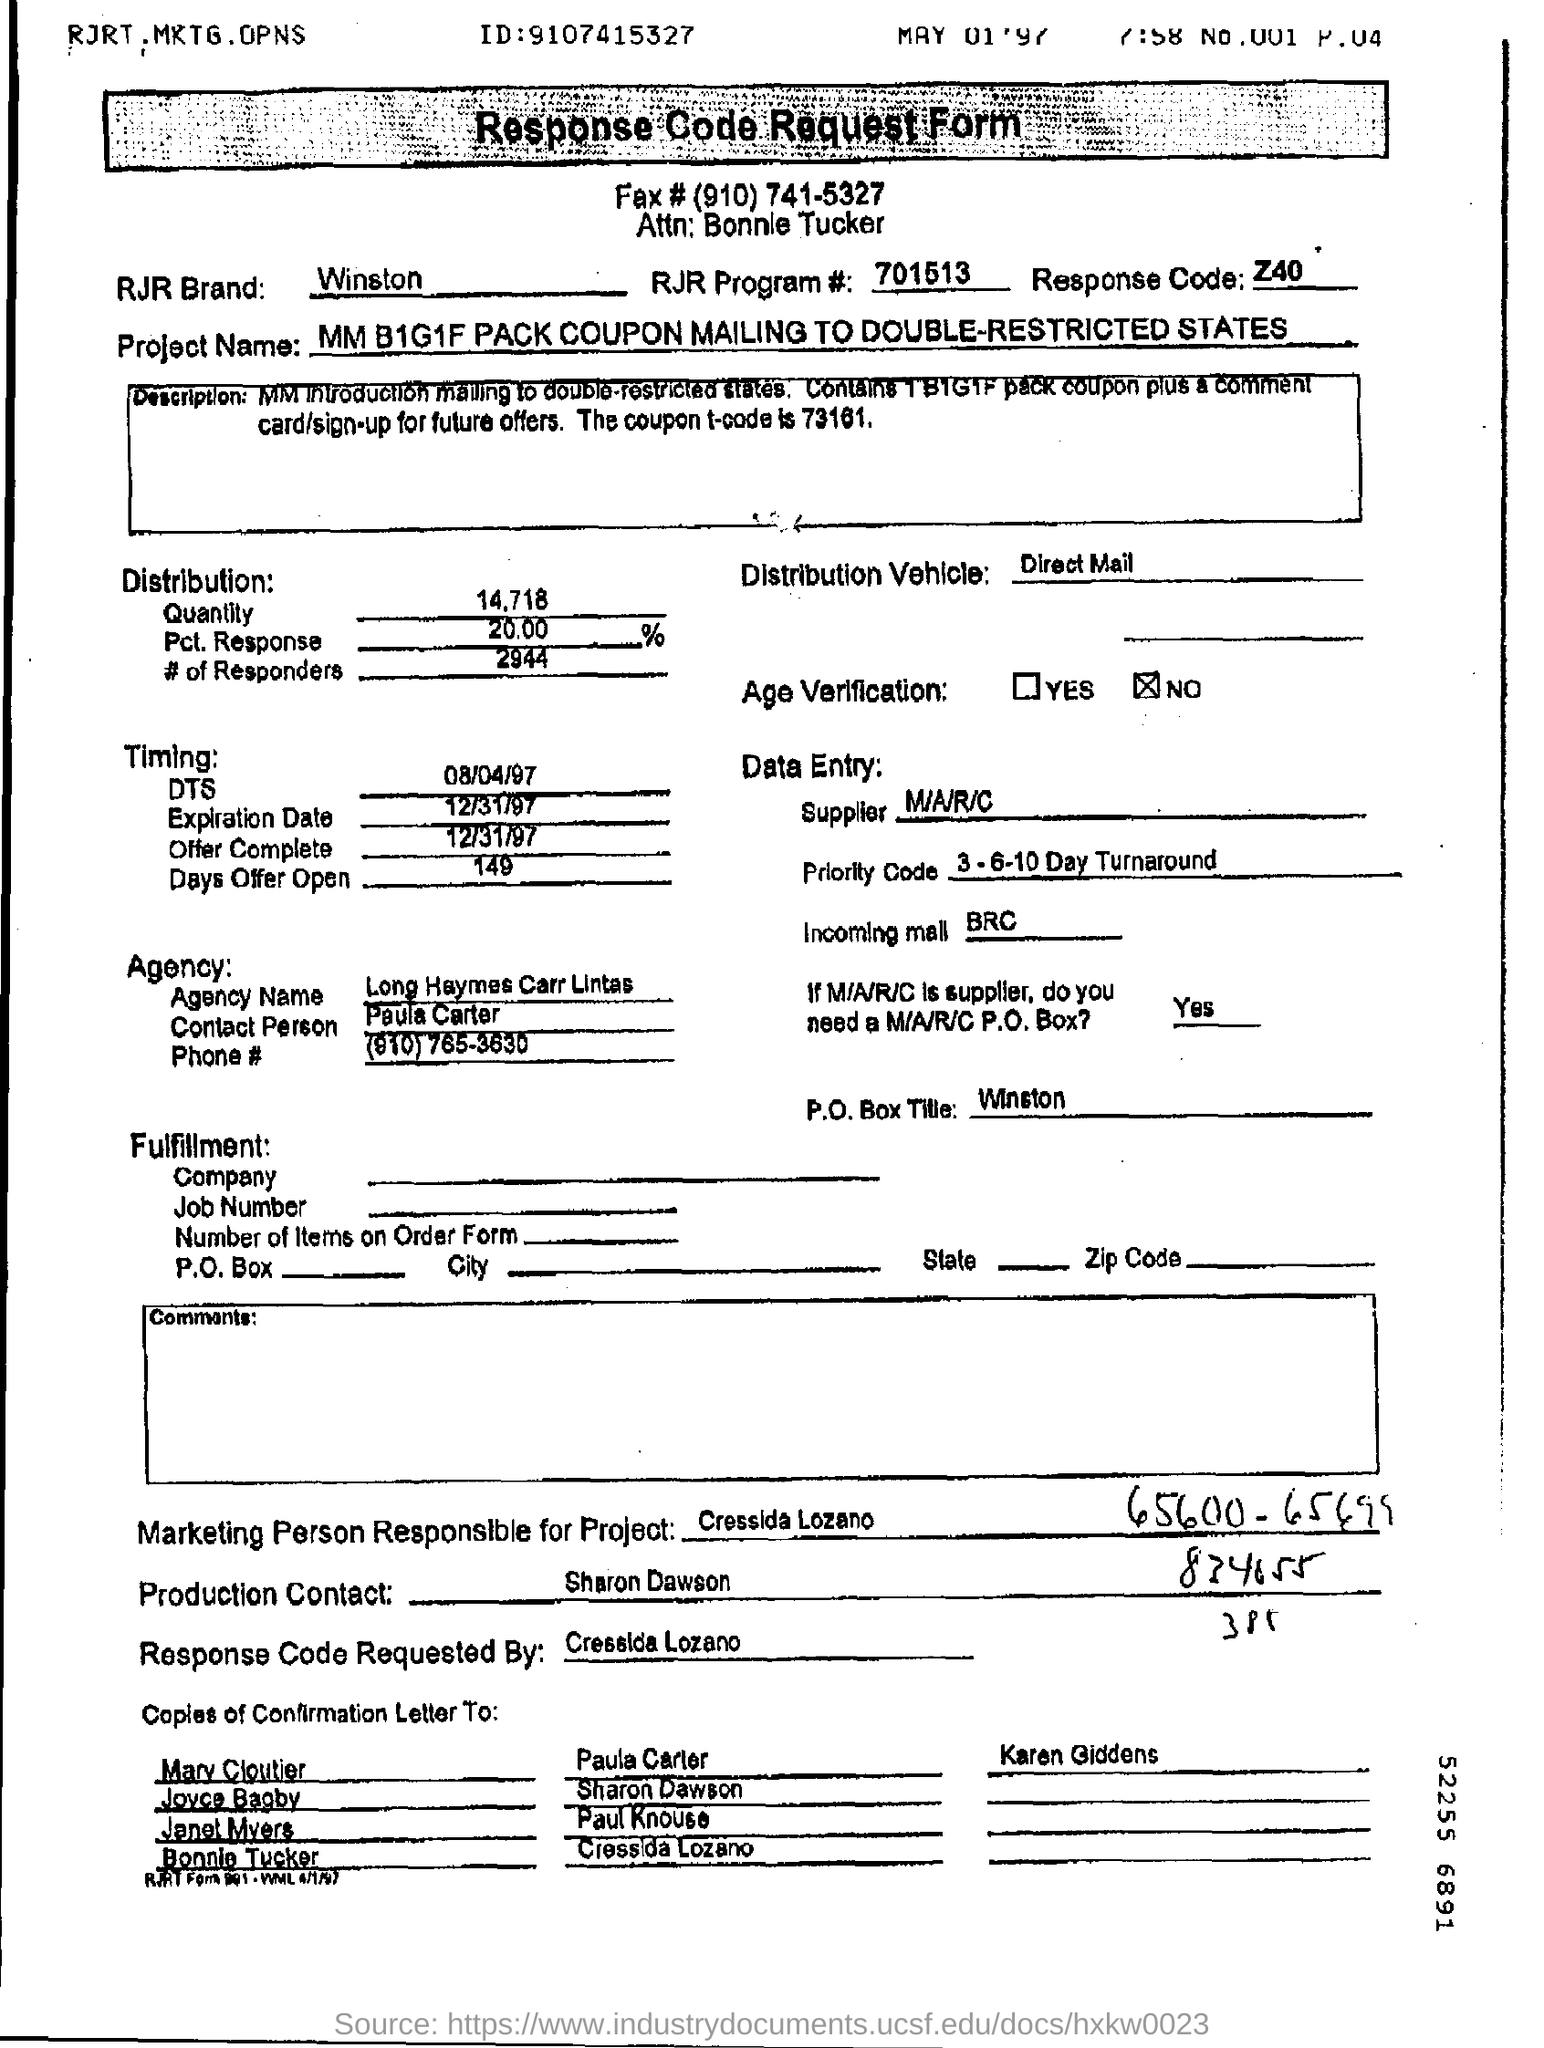How many Responders are there in the Distribution? The number of responders in the distribution is reported as 2,944 on the document. 